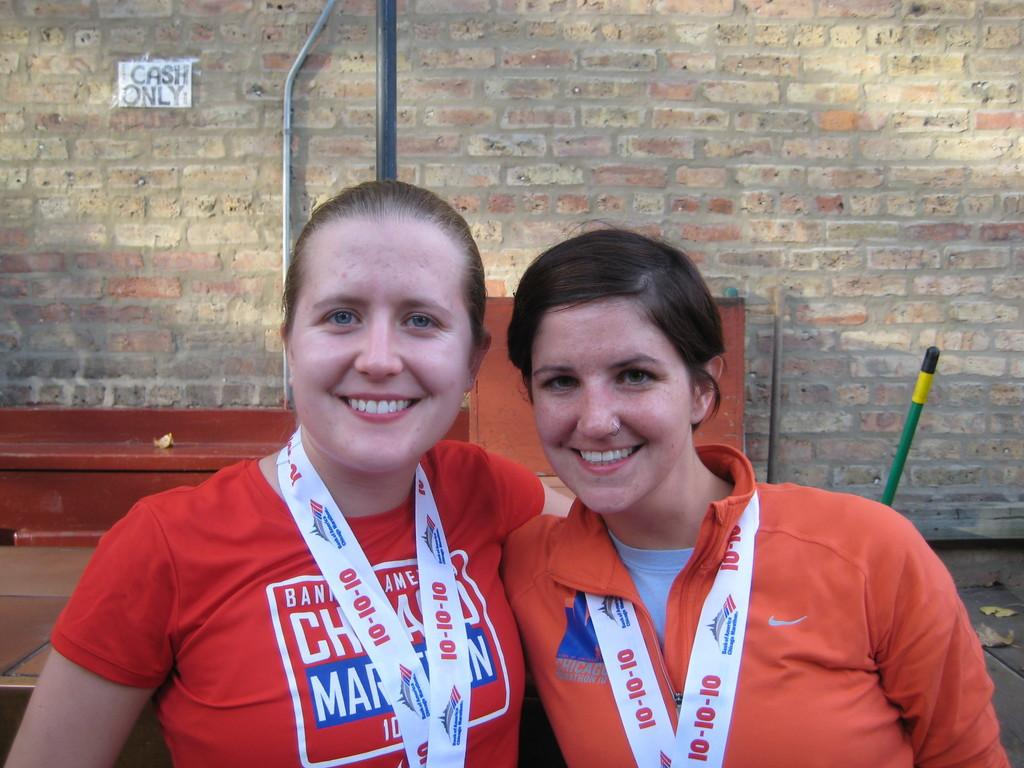<image>
Render a clear and concise summary of the photo. Two women wear lanyards that sayd Bank of America on them 